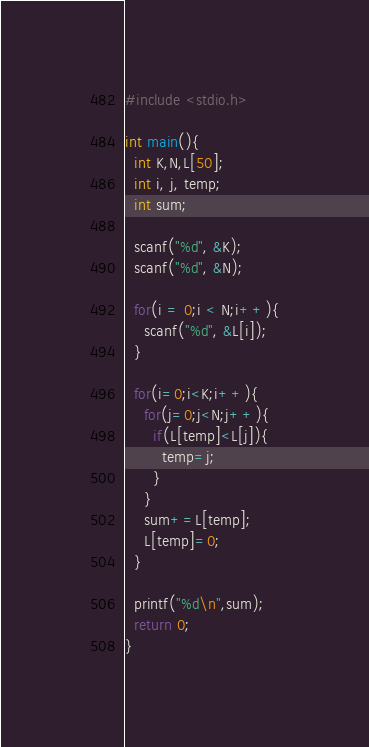Convert code to text. <code><loc_0><loc_0><loc_500><loc_500><_C_>#include <stdio.h>

int main(){
  int K,N,L[50];
  int i, j, temp;
  int sum;

  scanf("%d", &K);
  scanf("%d", &N);
  
  for(i = 0;i < N;i++){
    scanf("%d", &L[i]);
  }
  
  for(i=0;i<K;i++){
    for(j=0;j<N;j++){
      if(L[temp]<L[j]){
        temp=j;
      }
    }
    sum+=L[temp];
    L[temp]=0;
  }
  
  printf("%d\n",sum);
  return 0;
}</code> 